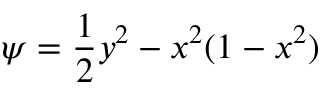<formula> <loc_0><loc_0><loc_500><loc_500>\psi = \frac { 1 } { 2 } y ^ { 2 } - x ^ { 2 } ( 1 - x ^ { 2 } )</formula> 